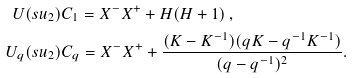Convert formula to latex. <formula><loc_0><loc_0><loc_500><loc_500>U ( s u _ { 2 } ) & C _ { 1 } = X ^ { - } X ^ { + } + H ( H + 1 ) \, , \\ U _ { q } ( s u _ { 2 } ) & C _ { q } = X ^ { - } X ^ { + } + \frac { ( K - K ^ { - 1 } ) ( q K - q ^ { - 1 } K ^ { - 1 } ) } { ( q - q ^ { - 1 } ) ^ { 2 } } .</formula> 